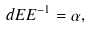<formula> <loc_0><loc_0><loc_500><loc_500>d E E ^ { - 1 } = \alpha ,</formula> 